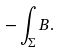<formula> <loc_0><loc_0><loc_500><loc_500>- \int _ { \Sigma } B .</formula> 